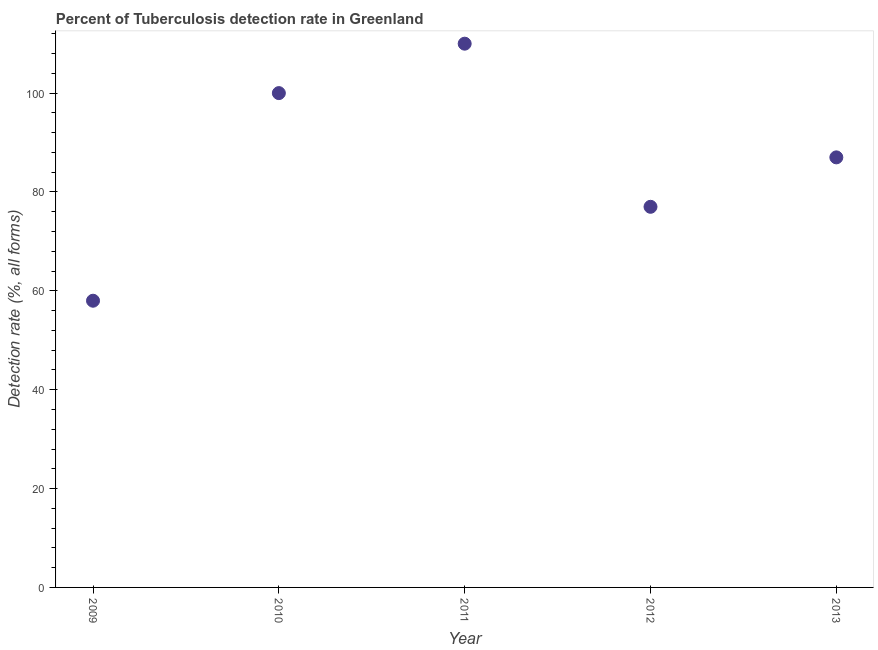What is the detection rate of tuberculosis in 2009?
Keep it short and to the point. 58. Across all years, what is the maximum detection rate of tuberculosis?
Your response must be concise. 110. Across all years, what is the minimum detection rate of tuberculosis?
Your response must be concise. 58. In which year was the detection rate of tuberculosis maximum?
Give a very brief answer. 2011. What is the sum of the detection rate of tuberculosis?
Make the answer very short. 432. What is the difference between the detection rate of tuberculosis in 2010 and 2011?
Your response must be concise. -10. What is the average detection rate of tuberculosis per year?
Your answer should be compact. 86.4. In how many years, is the detection rate of tuberculosis greater than 16 %?
Provide a short and direct response. 5. Do a majority of the years between 2009 and 2010 (inclusive) have detection rate of tuberculosis greater than 12 %?
Give a very brief answer. Yes. What is the ratio of the detection rate of tuberculosis in 2009 to that in 2010?
Offer a terse response. 0.58. Is the detection rate of tuberculosis in 2010 less than that in 2012?
Offer a terse response. No. Is the difference between the detection rate of tuberculosis in 2011 and 2013 greater than the difference between any two years?
Your answer should be compact. No. What is the difference between the highest and the second highest detection rate of tuberculosis?
Your response must be concise. 10. What is the difference between the highest and the lowest detection rate of tuberculosis?
Provide a short and direct response. 52. How many dotlines are there?
Your response must be concise. 1. Does the graph contain any zero values?
Provide a short and direct response. No. What is the title of the graph?
Make the answer very short. Percent of Tuberculosis detection rate in Greenland. What is the label or title of the Y-axis?
Your response must be concise. Detection rate (%, all forms). What is the Detection rate (%, all forms) in 2009?
Provide a short and direct response. 58. What is the Detection rate (%, all forms) in 2010?
Offer a very short reply. 100. What is the Detection rate (%, all forms) in 2011?
Keep it short and to the point. 110. What is the Detection rate (%, all forms) in 2012?
Provide a short and direct response. 77. What is the difference between the Detection rate (%, all forms) in 2009 and 2010?
Ensure brevity in your answer.  -42. What is the difference between the Detection rate (%, all forms) in 2009 and 2011?
Your answer should be compact. -52. What is the difference between the Detection rate (%, all forms) in 2011 and 2013?
Give a very brief answer. 23. What is the ratio of the Detection rate (%, all forms) in 2009 to that in 2010?
Provide a short and direct response. 0.58. What is the ratio of the Detection rate (%, all forms) in 2009 to that in 2011?
Keep it short and to the point. 0.53. What is the ratio of the Detection rate (%, all forms) in 2009 to that in 2012?
Make the answer very short. 0.75. What is the ratio of the Detection rate (%, all forms) in 2009 to that in 2013?
Provide a succinct answer. 0.67. What is the ratio of the Detection rate (%, all forms) in 2010 to that in 2011?
Keep it short and to the point. 0.91. What is the ratio of the Detection rate (%, all forms) in 2010 to that in 2012?
Make the answer very short. 1.3. What is the ratio of the Detection rate (%, all forms) in 2010 to that in 2013?
Make the answer very short. 1.15. What is the ratio of the Detection rate (%, all forms) in 2011 to that in 2012?
Your answer should be compact. 1.43. What is the ratio of the Detection rate (%, all forms) in 2011 to that in 2013?
Make the answer very short. 1.26. What is the ratio of the Detection rate (%, all forms) in 2012 to that in 2013?
Offer a terse response. 0.89. 